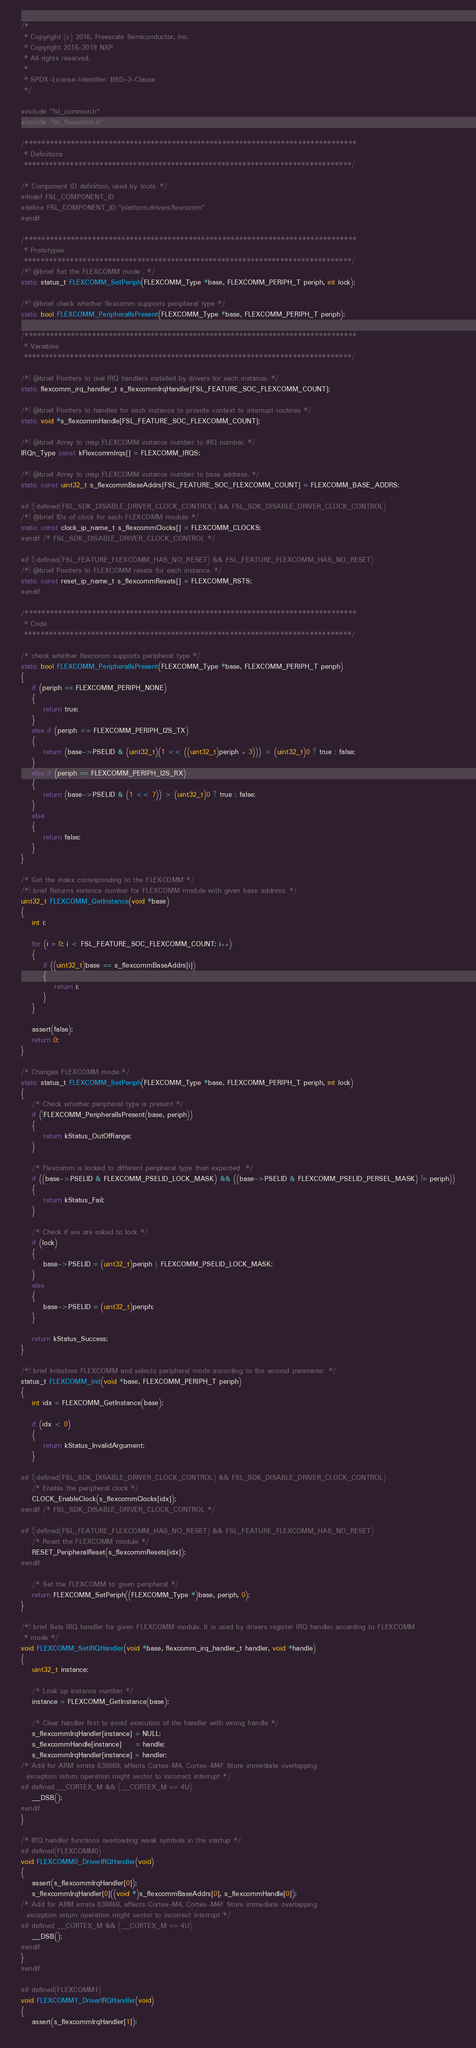Convert code to text. <code><loc_0><loc_0><loc_500><loc_500><_C_>/*
 * Copyright (c) 2016, Freescale Semiconductor, Inc.
 * Copyright 2016-2019 NXP
 * All rights reserved.
 *
 * SPDX-License-Identifier: BSD-3-Clause
 */

#include "fsl_common.h"
#include "fsl_flexcomm.h"

/*******************************************************************************
 * Definitions
 ******************************************************************************/

/* Component ID definition, used by tools. */
#ifndef FSL_COMPONENT_ID
#define FSL_COMPONENT_ID "platform.drivers.flexcomm"
#endif

/*******************************************************************************
 * Prototypes
 ******************************************************************************/
/*! @brief Set the FLEXCOMM mode . */
static status_t FLEXCOMM_SetPeriph(FLEXCOMM_Type *base, FLEXCOMM_PERIPH_T periph, int lock);

/*! @brief check whether flexcomm supports peripheral type */
static bool FLEXCOMM_PeripheralIsPresent(FLEXCOMM_Type *base, FLEXCOMM_PERIPH_T periph);

/*******************************************************************************
 * Variables
 ******************************************************************************/

/*! @brief Pointers to real IRQ handlers installed by drivers for each instance. */
static flexcomm_irq_handler_t s_flexcommIrqHandler[FSL_FEATURE_SOC_FLEXCOMM_COUNT];

/*! @brief Pointers to handles for each instance to provide context to interrupt routines */
static void *s_flexcommHandle[FSL_FEATURE_SOC_FLEXCOMM_COUNT];

/*! @brief Array to map FLEXCOMM instance number to IRQ number. */
IRQn_Type const kFlexcommIrqs[] = FLEXCOMM_IRQS;

/*! @brief Array to map FLEXCOMM instance number to base address. */
static const uint32_t s_flexcommBaseAddrs[FSL_FEATURE_SOC_FLEXCOMM_COUNT] = FLEXCOMM_BASE_ADDRS;

#if !(defined(FSL_SDK_DISABLE_DRIVER_CLOCK_CONTROL) && FSL_SDK_DISABLE_DRIVER_CLOCK_CONTROL)
/*! @brief IDs of clock for each FLEXCOMM module */
static const clock_ip_name_t s_flexcommClocks[] = FLEXCOMM_CLOCKS;
#endif /* FSL_SDK_DISABLE_DRIVER_CLOCK_CONTROL */

#if !(defined(FSL_FEATURE_FLEXCOMM_HAS_NO_RESET) && FSL_FEATURE_FLEXCOMM_HAS_NO_RESET)
/*! @brief Pointers to FLEXCOMM resets for each instance. */
static const reset_ip_name_t s_flexcommResets[] = FLEXCOMM_RSTS;
#endif

/*******************************************************************************
 * Code
 ******************************************************************************/

/* check whether flexcomm supports peripheral type */
static bool FLEXCOMM_PeripheralIsPresent(FLEXCOMM_Type *base, FLEXCOMM_PERIPH_T periph)
{
    if (periph == FLEXCOMM_PERIPH_NONE)
    {
        return true;
    }
    else if (periph <= FLEXCOMM_PERIPH_I2S_TX)
    {
        return (base->PSELID & (uint32_t)(1 << ((uint32_t)periph + 3))) > (uint32_t)0 ? true : false;
    }
    else if (periph == FLEXCOMM_PERIPH_I2S_RX)
    {
        return (base->PSELID & (1 << 7)) > (uint32_t)0 ? true : false;
    }
    else
    {
        return false;
    }
}

/* Get the index corresponding to the FLEXCOMM */
/*! brief Returns instance number for FLEXCOMM module with given base address. */
uint32_t FLEXCOMM_GetInstance(void *base)
{
    int i;

    for (i = 0; i < FSL_FEATURE_SOC_FLEXCOMM_COUNT; i++)
    {
        if ((uint32_t)base == s_flexcommBaseAddrs[i])
        {
            return i;
        }
    }

    assert(false);
    return 0;
}

/* Changes FLEXCOMM mode */
static status_t FLEXCOMM_SetPeriph(FLEXCOMM_Type *base, FLEXCOMM_PERIPH_T periph, int lock)
{
    /* Check whether peripheral type is present */
    if (!FLEXCOMM_PeripheralIsPresent(base, periph))
    {
        return kStatus_OutOfRange;
    }

    /* Flexcomm is locked to different peripheral type than expected  */
    if ((base->PSELID & FLEXCOMM_PSELID_LOCK_MASK) && ((base->PSELID & FLEXCOMM_PSELID_PERSEL_MASK) != periph))
    {
        return kStatus_Fail;
    }

    /* Check if we are asked to lock */
    if (lock)
    {
        base->PSELID = (uint32_t)periph | FLEXCOMM_PSELID_LOCK_MASK;
    }
    else
    {
        base->PSELID = (uint32_t)periph;
    }

    return kStatus_Success;
}

/*! brief Initializes FLEXCOMM and selects peripheral mode according to the second parameter. */
status_t FLEXCOMM_Init(void *base, FLEXCOMM_PERIPH_T periph)
{
    int idx = FLEXCOMM_GetInstance(base);

    if (idx < 0)
    {
        return kStatus_InvalidArgument;
    }

#if !(defined(FSL_SDK_DISABLE_DRIVER_CLOCK_CONTROL) && FSL_SDK_DISABLE_DRIVER_CLOCK_CONTROL)
    /* Enable the peripheral clock */
    CLOCK_EnableClock(s_flexcommClocks[idx]);
#endif /* FSL_SDK_DISABLE_DRIVER_CLOCK_CONTROL */

#if !(defined(FSL_FEATURE_FLEXCOMM_HAS_NO_RESET) && FSL_FEATURE_FLEXCOMM_HAS_NO_RESET)
    /* Reset the FLEXCOMM module */
    RESET_PeripheralReset(s_flexcommResets[idx]);
#endif

    /* Set the FLEXCOMM to given peripheral */
    return FLEXCOMM_SetPeriph((FLEXCOMM_Type *)base, periph, 0);
}

/*! brief Sets IRQ handler for given FLEXCOMM module. It is used by drivers register IRQ handler according to FLEXCOMM
 * mode */
void FLEXCOMM_SetIRQHandler(void *base, flexcomm_irq_handler_t handler, void *handle)
{
    uint32_t instance;

    /* Look up instance number */
    instance = FLEXCOMM_GetInstance(base);

    /* Clear handler first to avoid execution of the handler with wrong handle */
    s_flexcommIrqHandler[instance] = NULL;
    s_flexcommHandle[instance]     = handle;
    s_flexcommIrqHandler[instance] = handler;
/* Add for ARM errata 838869, affects Cortex-M4, Cortex-M4F Store immediate overlapping
  exception return operation might vector to incorrect interrupt */
#if defined __CORTEX_M && (__CORTEX_M == 4U)
    __DSB();
#endif
}

/* IRQ handler functions overloading weak symbols in the startup */
#if defined(FLEXCOMM0)
void FLEXCOMM0_DriverIRQHandler(void)
{
    assert(s_flexcommIrqHandler[0]);
    s_flexcommIrqHandler[0]((void *)s_flexcommBaseAddrs[0], s_flexcommHandle[0]);
/* Add for ARM errata 838869, affects Cortex-M4, Cortex-M4F Store immediate overlapping
  exception return operation might vector to incorrect interrupt */
#if defined __CORTEX_M && (__CORTEX_M == 4U)
    __DSB();
#endif
}
#endif

#if defined(FLEXCOMM1)
void FLEXCOMM1_DriverIRQHandler(void)
{
    assert(s_flexcommIrqHandler[1]);</code> 